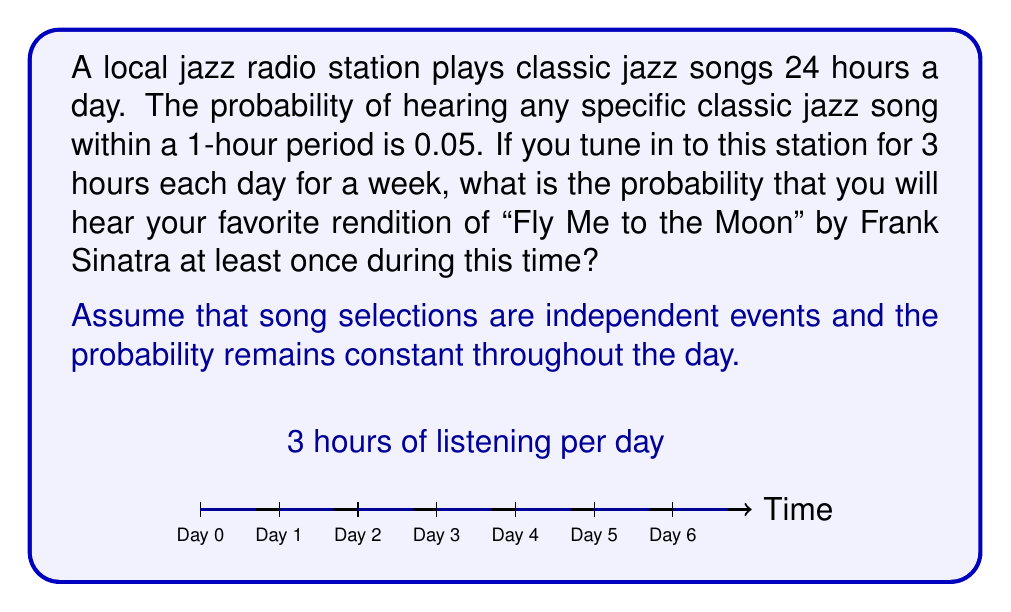Could you help me with this problem? Let's approach this step-by-step:

1) First, we need to calculate the probability of not hearing the song in a single hour:
   $P(\text{not hearing in 1 hour}) = 1 - 0.05 = 0.95$

2) In one day, you listen for 3 hours. The probability of not hearing the song in these 3 hours is:
   $P(\text{not hearing in 3 hours}) = (0.95)^3 = 0.857375$

3) You listen for 7 days. The probability of not hearing the song at all during the week is:
   $P(\text{not hearing in a week}) = (0.857375)^7 = 0.3434$

4) Therefore, the probability of hearing the song at least once during the week is:
   $P(\text{hearing at least once}) = 1 - P(\text{not hearing in a week})$
   $= 1 - 0.3434 = 0.6566$

5) We can express this as a percentage:
   $0.6566 \times 100\% = 65.66\%$

This problem utilizes the concept of complementary events and the multiplication rule for independent events in probability theory.
Answer: 65.66% 